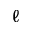<formula> <loc_0><loc_0><loc_500><loc_500>\ell</formula> 